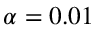<formula> <loc_0><loc_0><loc_500><loc_500>\alpha = 0 . 0 1</formula> 